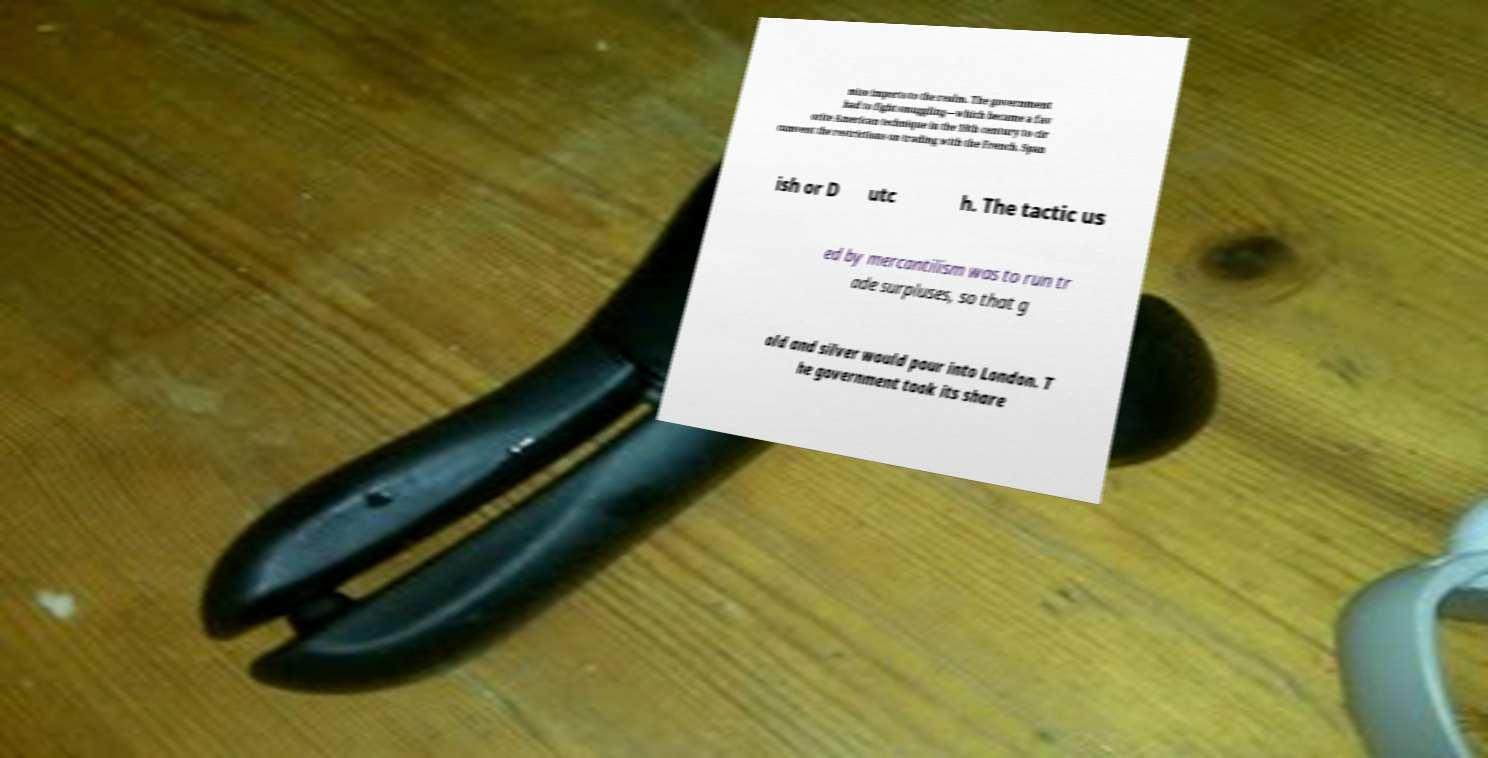There's text embedded in this image that I need extracted. Can you transcribe it verbatim? mize imports to the realm. The government had to fight smuggling—which became a fav orite American technique in the 18th century to cir cumvent the restrictions on trading with the French, Span ish or D utc h. The tactic us ed by mercantilism was to run tr ade surpluses, so that g old and silver would pour into London. T he government took its share 